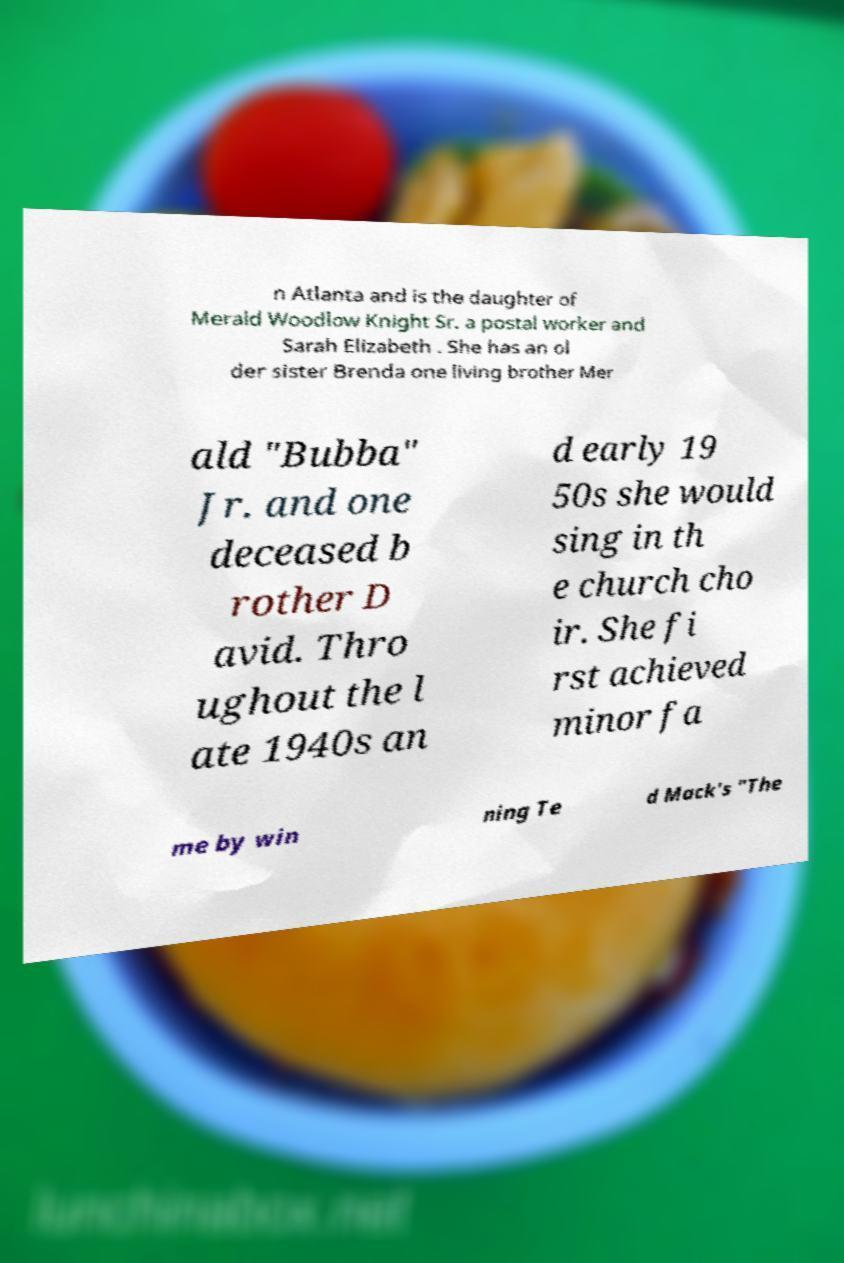Could you extract and type out the text from this image? n Atlanta and is the daughter of Merald Woodlow Knight Sr. a postal worker and Sarah Elizabeth . She has an ol der sister Brenda one living brother Mer ald "Bubba" Jr. and one deceased b rother D avid. Thro ughout the l ate 1940s an d early 19 50s she would sing in th e church cho ir. She fi rst achieved minor fa me by win ning Te d Mack's "The 